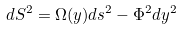<formula> <loc_0><loc_0><loc_500><loc_500>d S ^ { 2 } = \Omega ( y ) d s ^ { 2 } - \Phi ^ { 2 } d y ^ { 2 }</formula> 